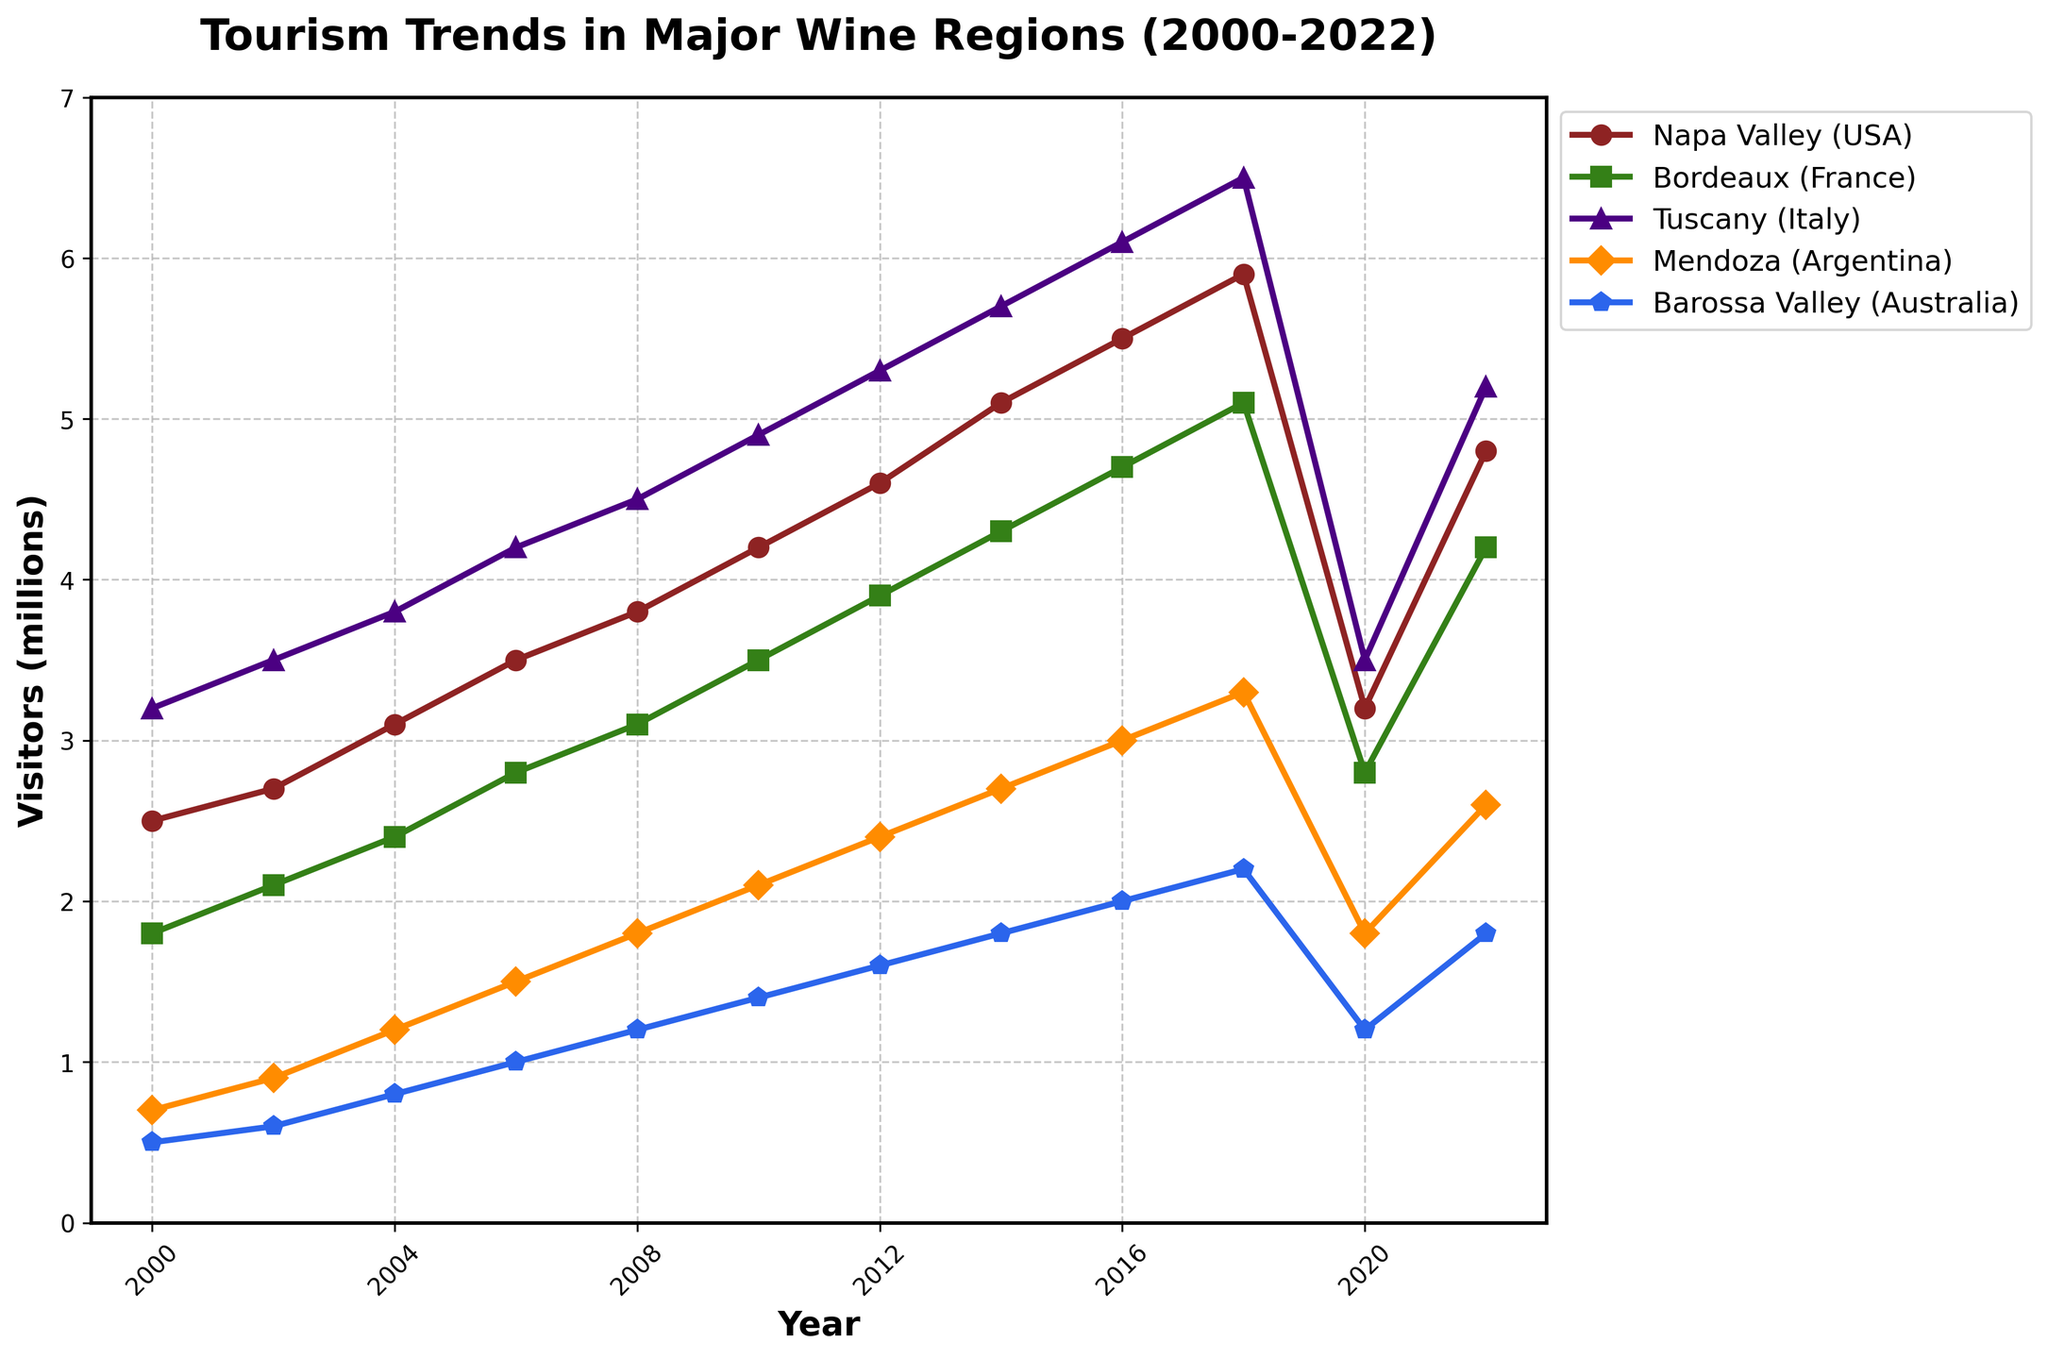Which wine region had the highest number of visitors in 2022? Check the figure and look for the data points for the year 2022. Observe the heights of the points and identify the highest one.
Answer: Tuscany (Italy) How did visitor numbers in Mendoza (Argentina) change from 2008 to 2012? Identify the points for Mendoza in the years 2008 and 2012. Calculate the difference: 2.4 - 1.8 = 0.6.
Answer: Increased by 0.6 million Which wine region showed the most significant drop in visitor numbers between 2018 and 2020? Compare the heights of the data points for all regions between 2018 and 2020. Calculate the differences and find the highest drop: Napa Valley (5.9 - 3.2) = 2.7 million.
Answer: Napa Valley (USA) What was the average number of visitors for the Barossa Valley (Australia) from 2000 to 2022? Summarize the data points for Barossa Valley (0.5, 0.6, 0.8, 1.0, 1.2, 1.4, 1.6, 1.8, 2.0, 2.2, 1.2, 1.8), then divide by the number of years: (15.1 / 12) ≈ 1.258.
Answer: Approximately 1.26 million Compare the growth in visitor numbers between Bordeaux (France) and Tuscany (Italy) from 2000 to 2018. Which had higher growth? Calculate 2018 visitors minus 2000 visitors: Bordeaux (5.1 - 1.8) = 3.3 million, Tuscany (6.5 - 3.2) = 3.3 million. Both have the same growth.
Answer: Both had equal growth (3.3 million) Which year showed the highest visitor numbers in Napa Valley (USA)? Check the peaks for the Napa Valley line over the years. The highest visitor number is at 2018 with 5.9 million visitors.
Answer: 2018 What was the economic impact trend in Barossa Valley (Australia) from 2000 to 2022? Explain using the trend of visitor numbers. Visually observe the steady increase from 0.5 million in 2000 to 2.2 million in 2018, then a dip to 1.2 million in 2020, and a slight rise to 1.8 million in 2022.
Answer: Increasing trend with a dip in 2020 Did Mendoza (Argentina) consistently grow in visitor numbers from 2000 to 2022? Trace the line for Mendoza from 2000 to 2022 and note any rises and falls. The numbers consistently rise from 2000 to 2018, then fall in 2020, followed by a recovery in 2022.
Answer: No Between 2010 and 2018, which region had the most significant increase in visitors? Calculate differences between 2010 and 2018 for all regions, choose highest: Napa Valley (5.9 - 4.2) = 1.7 million.
Answer: Napa Valley (USA) What are the visual trends observed for Tuscany (Italy) compared to Bordeaux (France) over the years? Observe both lines' directions and slopes. Tuscany shows a steady rise over the years with a slight dip in 2020, whereas Bordeaux has a more gradual rise with a dip and quick recovery.
Answer: Steady rise and dip for both but Tuscany has a steeper overall increase 